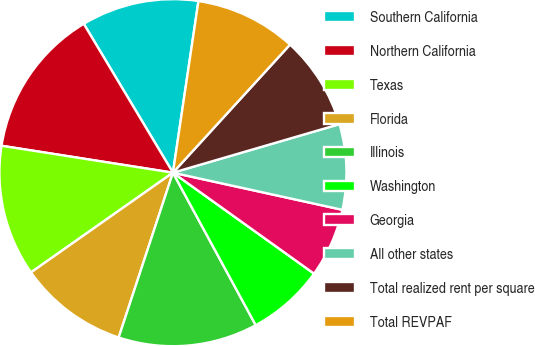<chart> <loc_0><loc_0><loc_500><loc_500><pie_chart><fcel>Southern California<fcel>Northern California<fcel>Texas<fcel>Florida<fcel>Illinois<fcel>Washington<fcel>Georgia<fcel>All other states<fcel>Total realized rent per square<fcel>Total REVPAF<nl><fcel>10.94%<fcel>13.93%<fcel>12.23%<fcel>10.19%<fcel>12.98%<fcel>7.2%<fcel>6.45%<fcel>7.95%<fcel>8.7%<fcel>9.44%<nl></chart> 